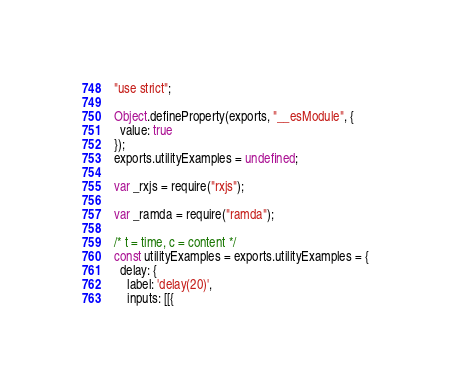Convert code to text. <code><loc_0><loc_0><loc_500><loc_500><_JavaScript_>"use strict";

Object.defineProperty(exports, "__esModule", {
  value: true
});
exports.utilityExamples = undefined;

var _rxjs = require("rxjs");

var _ramda = require("ramda");

/* t = time, c = content */
const utilityExamples = exports.utilityExamples = {
  delay: {
    label: 'delay(20)',
    inputs: [[{</code> 